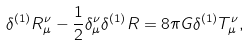Convert formula to latex. <formula><loc_0><loc_0><loc_500><loc_500>\delta ^ { ( 1 ) } R _ { \mu } ^ { \nu } - \frac { 1 } { 2 } \delta _ { \mu } ^ { \nu } \delta ^ { ( 1 ) } R = 8 \pi G \delta ^ { ( 1 ) } T _ { \mu } ^ { \nu } ,</formula> 